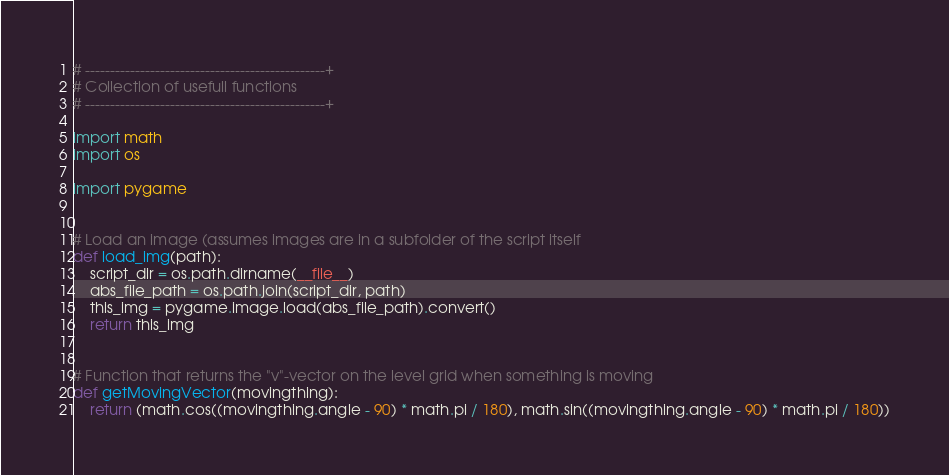<code> <loc_0><loc_0><loc_500><loc_500><_Python_># ------------------------------------------------+
# Collection of usefull functions
# ------------------------------------------------+

import math
import os

import pygame


# Load an image (assumes images are in a subfolder of the script itself
def load_img(path):
    script_dir = os.path.dirname(__file__)
    abs_file_path = os.path.join(script_dir, path)
    this_img = pygame.image.load(abs_file_path).convert()
    return this_img


# Function that returns the "v"-vector on the level grid when something is moving
def getMovingVector(movingthing):
    return (math.cos((movingthing.angle - 90) * math.pi / 180), math.sin((movingthing.angle - 90) * math.pi / 180))</code> 